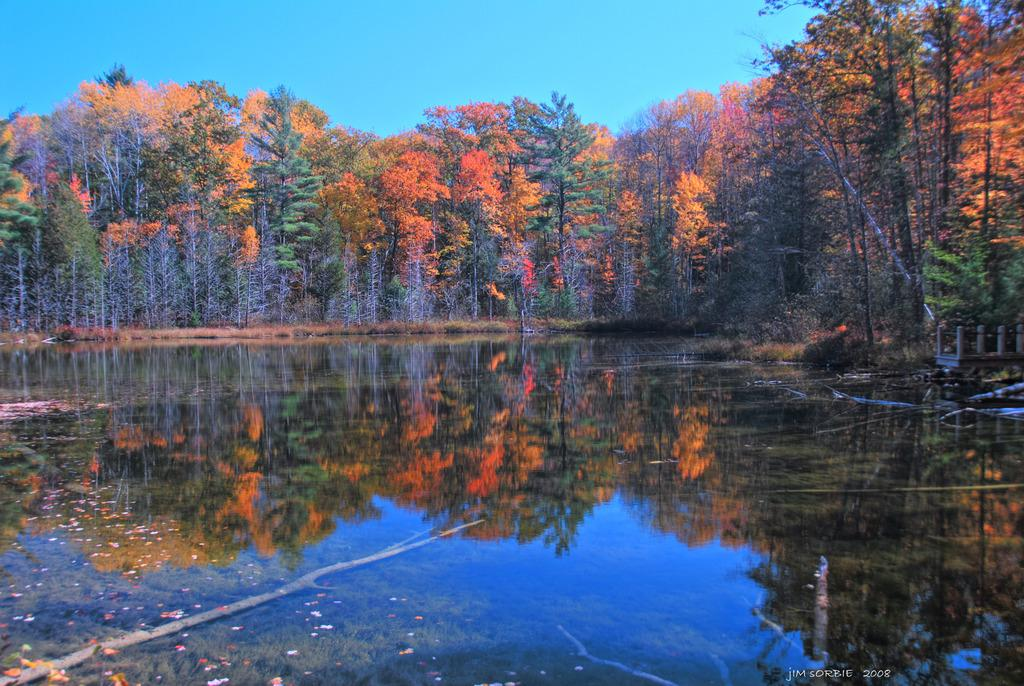What is the main subject in the center of the image? There is water in the center of the image. What can be seen in the background of the image? There are flower trees in the background area of the image. Are there any spies hiding among the flower trees in the image? There is no indication of spies or any hidden figures in the image; it only features water and flower trees. 